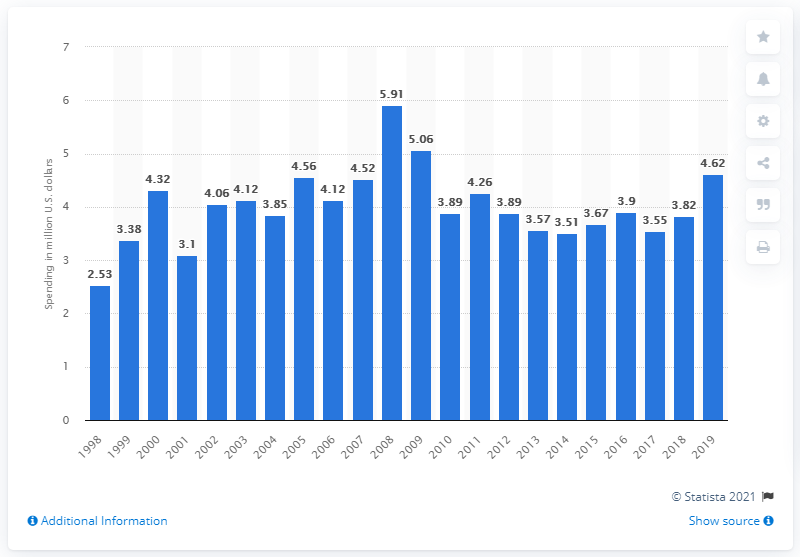Outline some significant characteristics in this image. In 2019, Disney spent $4.62 million on lobbying. 